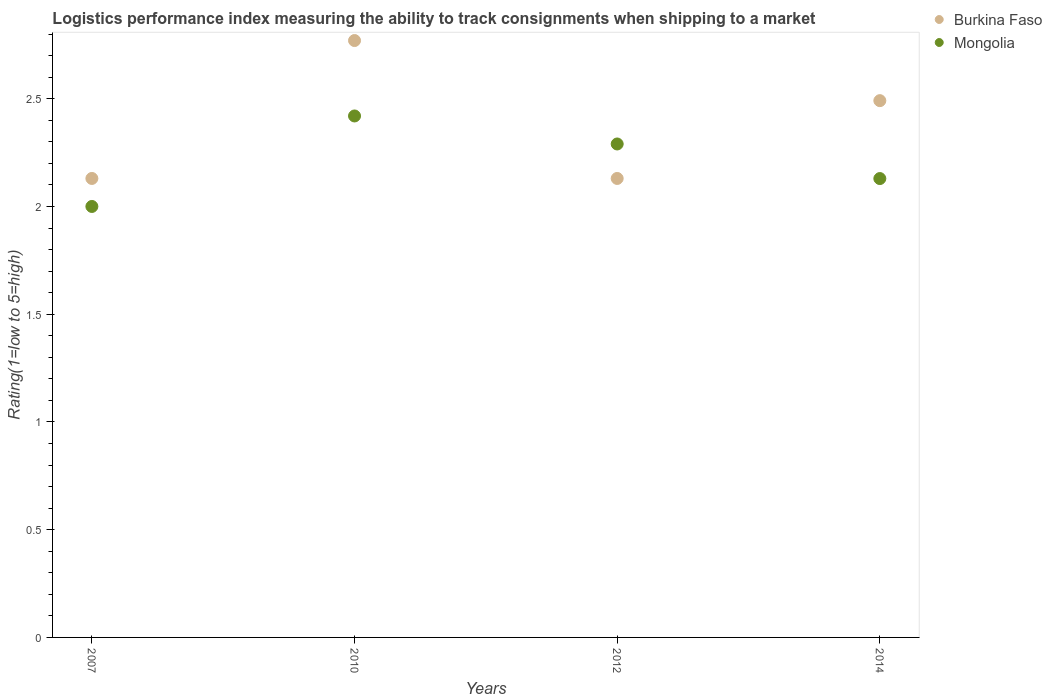How many different coloured dotlines are there?
Provide a succinct answer. 2. Is the number of dotlines equal to the number of legend labels?
Provide a short and direct response. Yes. What is the Logistic performance index in Mongolia in 2007?
Offer a terse response. 2. Across all years, what is the maximum Logistic performance index in Mongolia?
Keep it short and to the point. 2.42. Across all years, what is the minimum Logistic performance index in Burkina Faso?
Your answer should be compact. 2.13. In which year was the Logistic performance index in Burkina Faso minimum?
Your answer should be very brief. 2007. What is the total Logistic performance index in Burkina Faso in the graph?
Your answer should be very brief. 9.52. What is the difference between the Logistic performance index in Mongolia in 2007 and that in 2012?
Your response must be concise. -0.29. What is the difference between the Logistic performance index in Burkina Faso in 2014 and the Logistic performance index in Mongolia in 2012?
Your answer should be compact. 0.2. What is the average Logistic performance index in Burkina Faso per year?
Make the answer very short. 2.38. In the year 2010, what is the difference between the Logistic performance index in Mongolia and Logistic performance index in Burkina Faso?
Ensure brevity in your answer.  -0.35. What is the ratio of the Logistic performance index in Burkina Faso in 2012 to that in 2014?
Your response must be concise. 0.86. What is the difference between the highest and the second highest Logistic performance index in Mongolia?
Make the answer very short. 0.13. What is the difference between the highest and the lowest Logistic performance index in Burkina Faso?
Your answer should be very brief. 0.64. Does the Logistic performance index in Mongolia monotonically increase over the years?
Offer a terse response. No. Is the Logistic performance index in Mongolia strictly greater than the Logistic performance index in Burkina Faso over the years?
Keep it short and to the point. No. Is the Logistic performance index in Burkina Faso strictly less than the Logistic performance index in Mongolia over the years?
Give a very brief answer. No. How many dotlines are there?
Provide a short and direct response. 2. What is the difference between two consecutive major ticks on the Y-axis?
Keep it short and to the point. 0.5. Are the values on the major ticks of Y-axis written in scientific E-notation?
Offer a terse response. No. Where does the legend appear in the graph?
Offer a terse response. Top right. How are the legend labels stacked?
Your answer should be very brief. Vertical. What is the title of the graph?
Your answer should be compact. Logistics performance index measuring the ability to track consignments when shipping to a market. Does "Panama" appear as one of the legend labels in the graph?
Provide a short and direct response. No. What is the label or title of the X-axis?
Your response must be concise. Years. What is the label or title of the Y-axis?
Make the answer very short. Rating(1=low to 5=high). What is the Rating(1=low to 5=high) of Burkina Faso in 2007?
Provide a short and direct response. 2.13. What is the Rating(1=low to 5=high) in Mongolia in 2007?
Your answer should be compact. 2. What is the Rating(1=low to 5=high) of Burkina Faso in 2010?
Your answer should be compact. 2.77. What is the Rating(1=low to 5=high) of Mongolia in 2010?
Keep it short and to the point. 2.42. What is the Rating(1=low to 5=high) of Burkina Faso in 2012?
Provide a succinct answer. 2.13. What is the Rating(1=low to 5=high) of Mongolia in 2012?
Offer a very short reply. 2.29. What is the Rating(1=low to 5=high) in Burkina Faso in 2014?
Offer a very short reply. 2.49. What is the Rating(1=low to 5=high) of Mongolia in 2014?
Keep it short and to the point. 2.13. Across all years, what is the maximum Rating(1=low to 5=high) in Burkina Faso?
Offer a very short reply. 2.77. Across all years, what is the maximum Rating(1=low to 5=high) in Mongolia?
Give a very brief answer. 2.42. Across all years, what is the minimum Rating(1=low to 5=high) in Burkina Faso?
Make the answer very short. 2.13. What is the total Rating(1=low to 5=high) of Burkina Faso in the graph?
Your answer should be compact. 9.52. What is the total Rating(1=low to 5=high) of Mongolia in the graph?
Keep it short and to the point. 8.84. What is the difference between the Rating(1=low to 5=high) of Burkina Faso in 2007 and that in 2010?
Your answer should be compact. -0.64. What is the difference between the Rating(1=low to 5=high) in Mongolia in 2007 and that in 2010?
Offer a terse response. -0.42. What is the difference between the Rating(1=low to 5=high) of Mongolia in 2007 and that in 2012?
Make the answer very short. -0.29. What is the difference between the Rating(1=low to 5=high) in Burkina Faso in 2007 and that in 2014?
Keep it short and to the point. -0.36. What is the difference between the Rating(1=low to 5=high) of Mongolia in 2007 and that in 2014?
Keep it short and to the point. -0.13. What is the difference between the Rating(1=low to 5=high) in Burkina Faso in 2010 and that in 2012?
Provide a short and direct response. 0.64. What is the difference between the Rating(1=low to 5=high) of Mongolia in 2010 and that in 2012?
Offer a very short reply. 0.13. What is the difference between the Rating(1=low to 5=high) of Burkina Faso in 2010 and that in 2014?
Ensure brevity in your answer.  0.28. What is the difference between the Rating(1=low to 5=high) in Mongolia in 2010 and that in 2014?
Ensure brevity in your answer.  0.29. What is the difference between the Rating(1=low to 5=high) of Burkina Faso in 2012 and that in 2014?
Your answer should be compact. -0.36. What is the difference between the Rating(1=low to 5=high) of Mongolia in 2012 and that in 2014?
Provide a succinct answer. 0.16. What is the difference between the Rating(1=low to 5=high) in Burkina Faso in 2007 and the Rating(1=low to 5=high) in Mongolia in 2010?
Keep it short and to the point. -0.29. What is the difference between the Rating(1=low to 5=high) in Burkina Faso in 2007 and the Rating(1=low to 5=high) in Mongolia in 2012?
Provide a succinct answer. -0.16. What is the difference between the Rating(1=low to 5=high) in Burkina Faso in 2010 and the Rating(1=low to 5=high) in Mongolia in 2012?
Give a very brief answer. 0.48. What is the difference between the Rating(1=low to 5=high) in Burkina Faso in 2010 and the Rating(1=low to 5=high) in Mongolia in 2014?
Keep it short and to the point. 0.64. What is the difference between the Rating(1=low to 5=high) in Burkina Faso in 2012 and the Rating(1=low to 5=high) in Mongolia in 2014?
Offer a very short reply. 0. What is the average Rating(1=low to 5=high) of Burkina Faso per year?
Provide a short and direct response. 2.38. What is the average Rating(1=low to 5=high) in Mongolia per year?
Offer a terse response. 2.21. In the year 2007, what is the difference between the Rating(1=low to 5=high) in Burkina Faso and Rating(1=low to 5=high) in Mongolia?
Your answer should be very brief. 0.13. In the year 2010, what is the difference between the Rating(1=low to 5=high) of Burkina Faso and Rating(1=low to 5=high) of Mongolia?
Your answer should be very brief. 0.35. In the year 2012, what is the difference between the Rating(1=low to 5=high) in Burkina Faso and Rating(1=low to 5=high) in Mongolia?
Your answer should be very brief. -0.16. In the year 2014, what is the difference between the Rating(1=low to 5=high) in Burkina Faso and Rating(1=low to 5=high) in Mongolia?
Offer a very short reply. 0.36. What is the ratio of the Rating(1=low to 5=high) in Burkina Faso in 2007 to that in 2010?
Your response must be concise. 0.77. What is the ratio of the Rating(1=low to 5=high) of Mongolia in 2007 to that in 2010?
Give a very brief answer. 0.83. What is the ratio of the Rating(1=low to 5=high) of Burkina Faso in 2007 to that in 2012?
Give a very brief answer. 1. What is the ratio of the Rating(1=low to 5=high) of Mongolia in 2007 to that in 2012?
Ensure brevity in your answer.  0.87. What is the ratio of the Rating(1=low to 5=high) of Burkina Faso in 2007 to that in 2014?
Your answer should be very brief. 0.86. What is the ratio of the Rating(1=low to 5=high) of Mongolia in 2007 to that in 2014?
Provide a succinct answer. 0.94. What is the ratio of the Rating(1=low to 5=high) of Burkina Faso in 2010 to that in 2012?
Ensure brevity in your answer.  1.3. What is the ratio of the Rating(1=low to 5=high) in Mongolia in 2010 to that in 2012?
Provide a succinct answer. 1.06. What is the ratio of the Rating(1=low to 5=high) of Burkina Faso in 2010 to that in 2014?
Keep it short and to the point. 1.11. What is the ratio of the Rating(1=low to 5=high) in Mongolia in 2010 to that in 2014?
Your response must be concise. 1.14. What is the ratio of the Rating(1=low to 5=high) in Burkina Faso in 2012 to that in 2014?
Your answer should be compact. 0.86. What is the ratio of the Rating(1=low to 5=high) of Mongolia in 2012 to that in 2014?
Your answer should be compact. 1.08. What is the difference between the highest and the second highest Rating(1=low to 5=high) of Burkina Faso?
Your response must be concise. 0.28. What is the difference between the highest and the second highest Rating(1=low to 5=high) in Mongolia?
Provide a short and direct response. 0.13. What is the difference between the highest and the lowest Rating(1=low to 5=high) in Burkina Faso?
Give a very brief answer. 0.64. What is the difference between the highest and the lowest Rating(1=low to 5=high) in Mongolia?
Offer a very short reply. 0.42. 